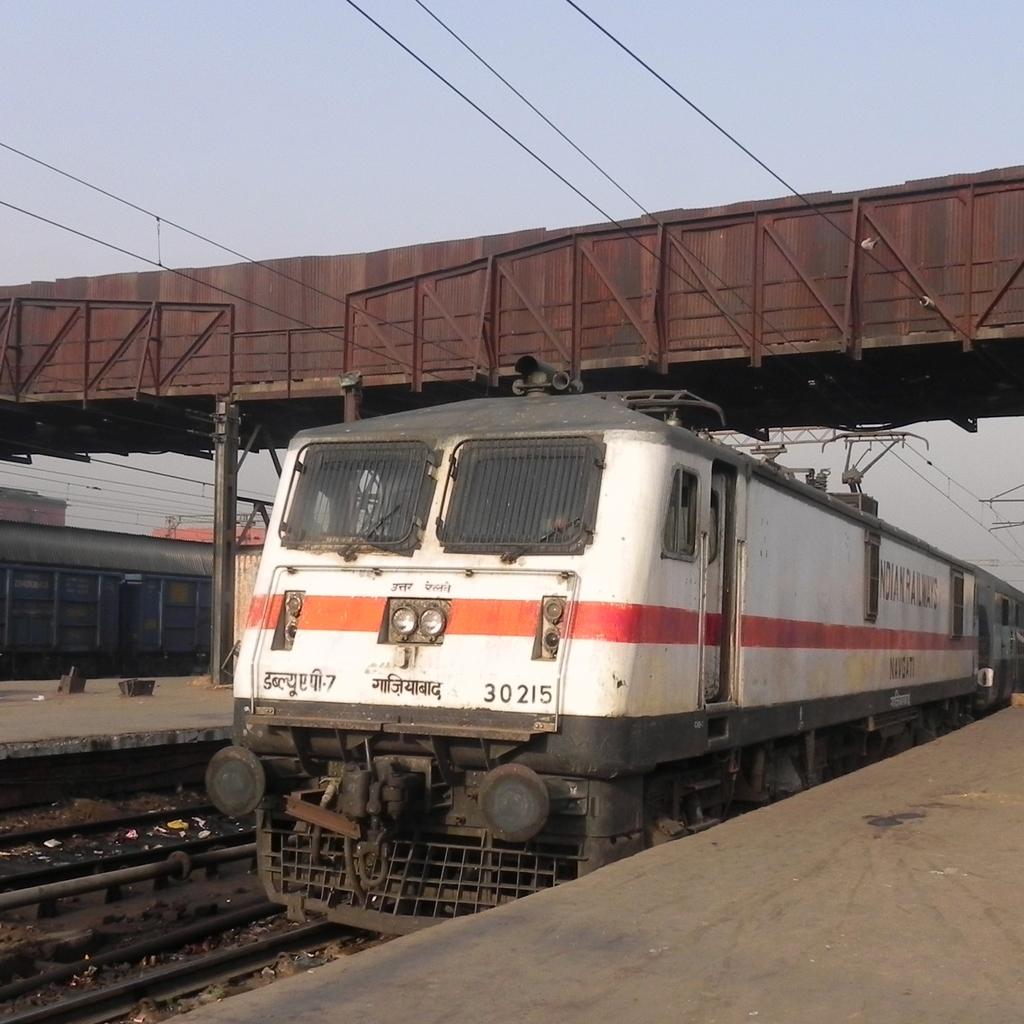What number is on the train?
Your answer should be very brief. 30215. 